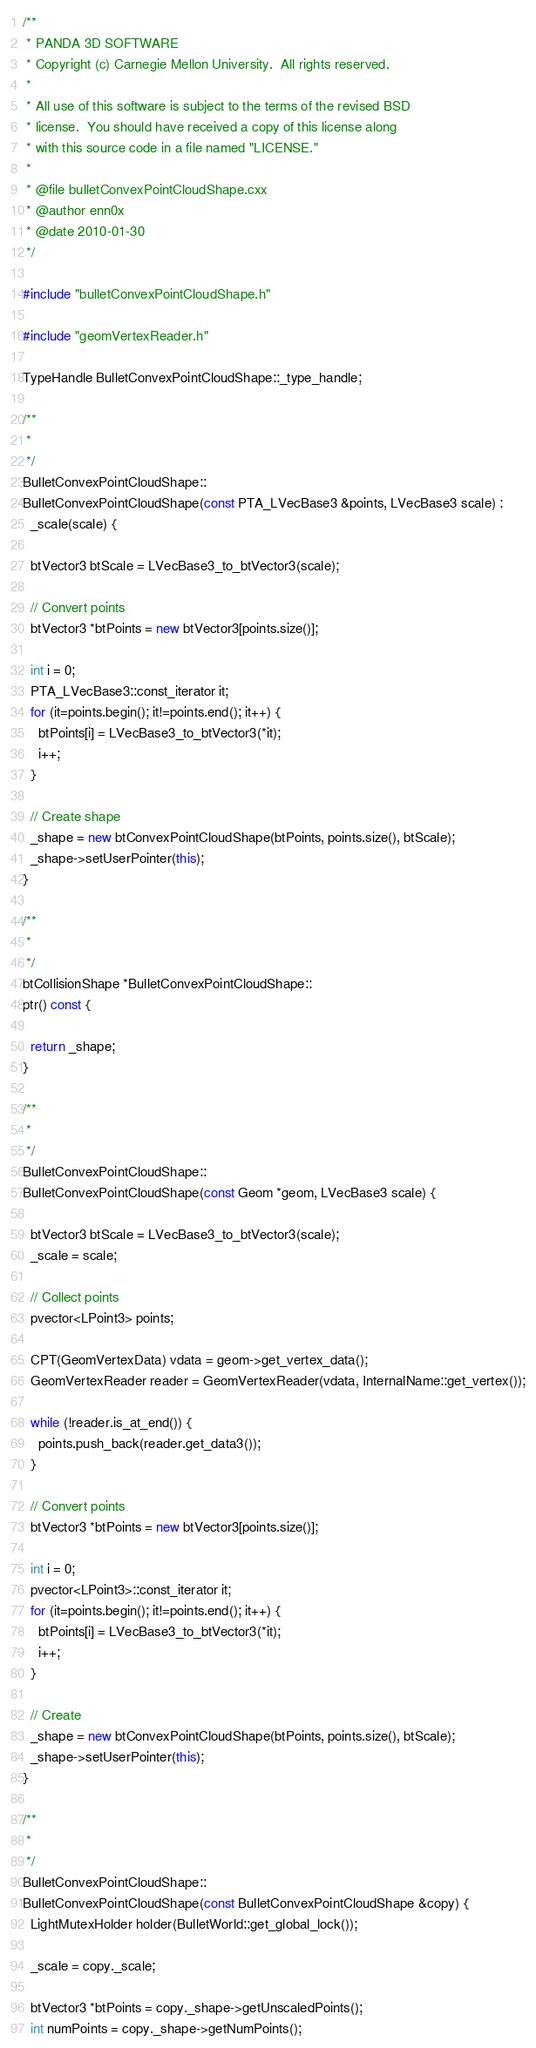Convert code to text. <code><loc_0><loc_0><loc_500><loc_500><_C++_>/**
 * PANDA 3D SOFTWARE
 * Copyright (c) Carnegie Mellon University.  All rights reserved.
 *
 * All use of this software is subject to the terms of the revised BSD
 * license.  You should have received a copy of this license along
 * with this source code in a file named "LICENSE."
 *
 * @file bulletConvexPointCloudShape.cxx
 * @author enn0x
 * @date 2010-01-30
 */

#include "bulletConvexPointCloudShape.h"

#include "geomVertexReader.h"

TypeHandle BulletConvexPointCloudShape::_type_handle;

/**
 *
 */
BulletConvexPointCloudShape::
BulletConvexPointCloudShape(const PTA_LVecBase3 &points, LVecBase3 scale) :
  _scale(scale) {

  btVector3 btScale = LVecBase3_to_btVector3(scale);

  // Convert points
  btVector3 *btPoints = new btVector3[points.size()];

  int i = 0;
  PTA_LVecBase3::const_iterator it;
  for (it=points.begin(); it!=points.end(); it++) {
    btPoints[i] = LVecBase3_to_btVector3(*it);
    i++;
  }

  // Create shape
  _shape = new btConvexPointCloudShape(btPoints, points.size(), btScale);
  _shape->setUserPointer(this);
}

/**
 *
 */
btCollisionShape *BulletConvexPointCloudShape::
ptr() const {

  return _shape;
}

/**
 *
 */
BulletConvexPointCloudShape::
BulletConvexPointCloudShape(const Geom *geom, LVecBase3 scale) {

  btVector3 btScale = LVecBase3_to_btVector3(scale);
  _scale = scale;

  // Collect points
  pvector<LPoint3> points;

  CPT(GeomVertexData) vdata = geom->get_vertex_data();
  GeomVertexReader reader = GeomVertexReader(vdata, InternalName::get_vertex());

  while (!reader.is_at_end()) {
    points.push_back(reader.get_data3());
  }

  // Convert points
  btVector3 *btPoints = new btVector3[points.size()];

  int i = 0;
  pvector<LPoint3>::const_iterator it;
  for (it=points.begin(); it!=points.end(); it++) {
    btPoints[i] = LVecBase3_to_btVector3(*it);
    i++;
  }

  // Create
  _shape = new btConvexPointCloudShape(btPoints, points.size(), btScale);
  _shape->setUserPointer(this);
}

/**
 *
 */
BulletConvexPointCloudShape::
BulletConvexPointCloudShape(const BulletConvexPointCloudShape &copy) {
  LightMutexHolder holder(BulletWorld::get_global_lock());

  _scale = copy._scale;

  btVector3 *btPoints = copy._shape->getUnscaledPoints();
  int numPoints = copy._shape->getNumPoints();</code> 